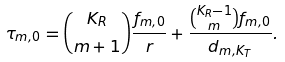Convert formula to latex. <formula><loc_0><loc_0><loc_500><loc_500>\tau _ { m , 0 } = \binom { K _ { R } } { m + 1 } \frac { f _ { m , 0 } } { r } + \frac { \binom { K _ { R } - 1 } { m } f _ { m , 0 } } { d _ { m , K _ { T } } } .</formula> 